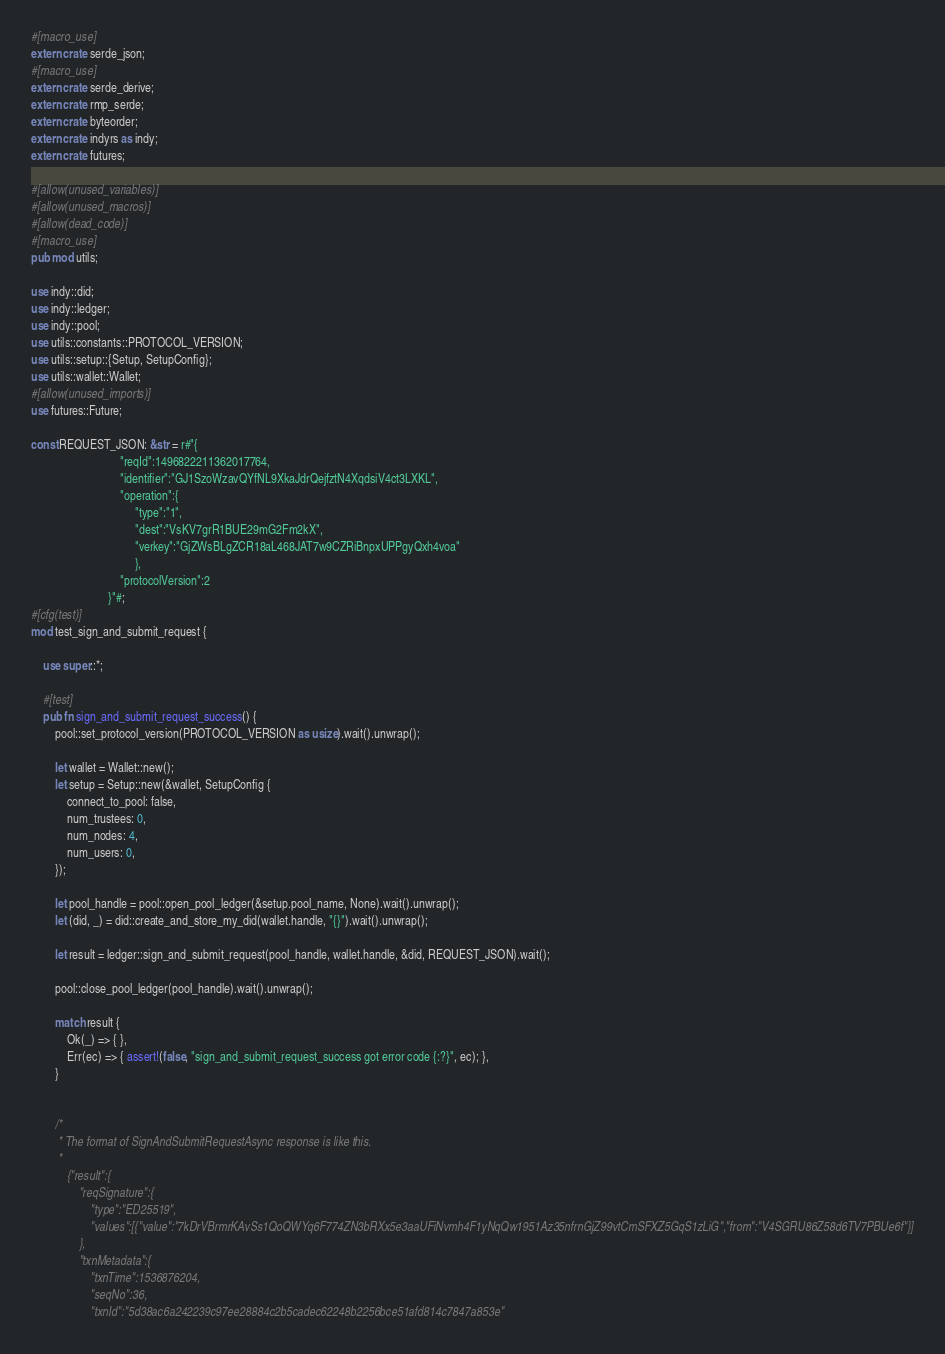<code> <loc_0><loc_0><loc_500><loc_500><_Rust_>#[macro_use]
extern crate serde_json;
#[macro_use]
extern crate serde_derive;
extern crate rmp_serde;
extern crate byteorder;
extern crate indyrs as indy;
extern crate futures;

#[allow(unused_variables)]
#[allow(unused_macros)]
#[allow(dead_code)]
#[macro_use]
pub mod utils;

use indy::did;
use indy::ledger;
use indy::pool;
use utils::constants::PROTOCOL_VERSION;
use utils::setup::{Setup, SetupConfig};
use utils::wallet::Wallet;
#[allow(unused_imports)]
use futures::Future;

const REQUEST_JSON: &str = r#"{
                              "reqId":1496822211362017764,
                              "identifier":"GJ1SzoWzavQYfNL9XkaJdrQejfztN4XqdsiV4ct3LXKL",
                              "operation":{
                                   "type":"1",
                                   "dest":"VsKV7grR1BUE29mG2Fm2kX",
                                   "verkey":"GjZWsBLgZCR18aL468JAT7w9CZRiBnpxUPPgyQxh4voa"
                                   },
                              "protocolVersion":2
                          }"#;
#[cfg(test)]
mod test_sign_and_submit_request {

    use super::*;

    #[test]
    pub fn sign_and_submit_request_success() {
        pool::set_protocol_version(PROTOCOL_VERSION as usize).wait().unwrap();

        let wallet = Wallet::new();
        let setup = Setup::new(&wallet, SetupConfig {
            connect_to_pool: false,
            num_trustees: 0,
            num_nodes: 4,
            num_users: 0,
        });

        let pool_handle = pool::open_pool_ledger(&setup.pool_name, None).wait().unwrap();
        let (did, _) = did::create_and_store_my_did(wallet.handle, "{}").wait().unwrap();

        let result = ledger::sign_and_submit_request(pool_handle, wallet.handle, &did, REQUEST_JSON).wait();

        pool::close_pool_ledger(pool_handle).wait().unwrap();

        match result {
            Ok(_) => { },
            Err(ec) => { assert!(false, "sign_and_submit_request_success got error code {:?}", ec); },
        }


        /*
         * The format of SignAndSubmitRequestAsync response is like this.
         *
            {"result":{
                "reqSignature":{
                    "type":"ED25519",
                    "values":[{"value":"7kDrVBrmrKAvSs1QoQWYq6F774ZN3bRXx5e3aaUFiNvmh4F1yNqQw1951Az35nfrnGjZ99vtCmSFXZ5GqS1zLiG","from":"V4SGRU86Z58d6TV7PBUe6f"}]
                },
                "txnMetadata":{
                    "txnTime":1536876204,
                    "seqNo":36,
                    "txnId":"5d38ac6a242239c97ee28884c2b5cadec62248b2256bce51afd814c7847a853e"</code> 